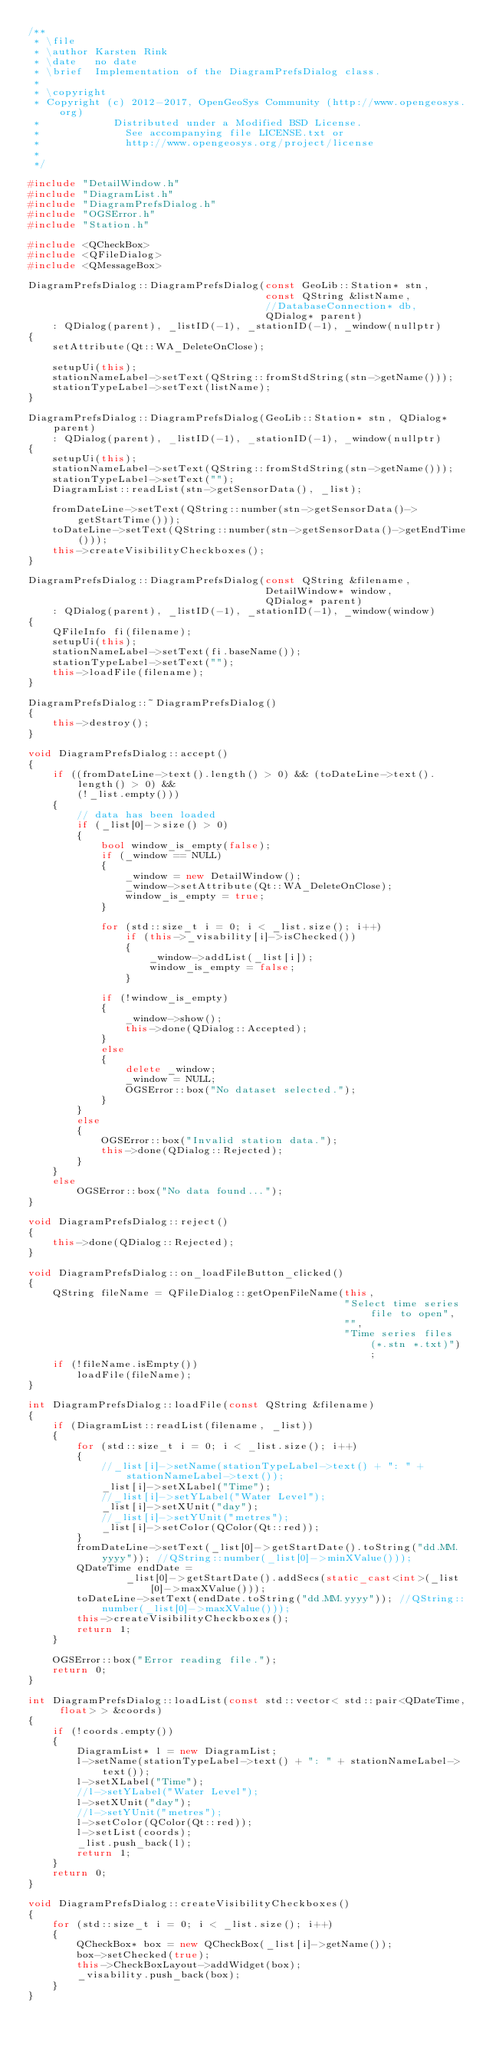Convert code to text. <code><loc_0><loc_0><loc_500><loc_500><_C++_>/**
 * \file
 * \author Karsten Rink
 * \date   no date
 * \brief  Implementation of the DiagramPrefsDialog class.
 *
 * \copyright
 * Copyright (c) 2012-2017, OpenGeoSys Community (http://www.opengeosys.org)
 *            Distributed under a Modified BSD License.
 *              See accompanying file LICENSE.txt or
 *              http://www.opengeosys.org/project/license
 *
 */

#include "DetailWindow.h"
#include "DiagramList.h"
#include "DiagramPrefsDialog.h"
#include "OGSError.h"
#include "Station.h"

#include <QCheckBox>
#include <QFileDialog>
#include <QMessageBox>

DiagramPrefsDialog::DiagramPrefsDialog(const GeoLib::Station* stn,
                                       const QString &listName,
                                       //DatabaseConnection* db,
                                       QDialog* parent)
    : QDialog(parent), _listID(-1), _stationID(-1), _window(nullptr)
{
    setAttribute(Qt::WA_DeleteOnClose);

    setupUi(this);
    stationNameLabel->setText(QString::fromStdString(stn->getName()));
    stationTypeLabel->setText(listName);
}

DiagramPrefsDialog::DiagramPrefsDialog(GeoLib::Station* stn, QDialog* parent)
    : QDialog(parent), _listID(-1), _stationID(-1), _window(nullptr)
{
    setupUi(this);
    stationNameLabel->setText(QString::fromStdString(stn->getName()));
    stationTypeLabel->setText("");
    DiagramList::readList(stn->getSensorData(), _list);

    fromDateLine->setText(QString::number(stn->getSensorData()->getStartTime()));
    toDateLine->setText(QString::number(stn->getSensorData()->getEndTime()));
    this->createVisibilityCheckboxes();
}

DiagramPrefsDialog::DiagramPrefsDialog(const QString &filename,
                                       DetailWindow* window,
                                       QDialog* parent)
    : QDialog(parent), _listID(-1), _stationID(-1), _window(window)
{
    QFileInfo fi(filename);
    setupUi(this);
    stationNameLabel->setText(fi.baseName());
    stationTypeLabel->setText("");
    this->loadFile(filename);
}

DiagramPrefsDialog::~DiagramPrefsDialog()
{
    this->destroy();
}

void DiagramPrefsDialog::accept()
{
    if ((fromDateLine->text().length() > 0) && (toDateLine->text().length() > 0) &&
        (!_list.empty()))
    {
        // data has been loaded
        if (_list[0]->size() > 0)
        {
            bool window_is_empty(false);
            if (_window == NULL)
            {
                _window = new DetailWindow();
                _window->setAttribute(Qt::WA_DeleteOnClose);
                window_is_empty = true;
            }

            for (std::size_t i = 0; i < _list.size(); i++)
                if (this->_visability[i]->isChecked())
                {
                    _window->addList(_list[i]);
                    window_is_empty = false;
                }

            if (!window_is_empty)
            {
                _window->show();
                this->done(QDialog::Accepted);
            }
            else
            {
                delete _window;
                _window = NULL;
                OGSError::box("No dataset selected.");
            }
        }
        else
        {
            OGSError::box("Invalid station data.");
            this->done(QDialog::Rejected);
        }
    }
    else
        OGSError::box("No data found...");
}

void DiagramPrefsDialog::reject()
{
    this->done(QDialog::Rejected);
}

void DiagramPrefsDialog::on_loadFileButton_clicked()
{
    QString fileName = QFileDialog::getOpenFileName(this,
                                                    "Select time series file to open",
                                                    "",
                                                    "Time series files (*.stn *.txt)");
    if (!fileName.isEmpty())
        loadFile(fileName);
}

int DiagramPrefsDialog::loadFile(const QString &filename)
{
    if (DiagramList::readList(filename, _list))
    {
        for (std::size_t i = 0; i < _list.size(); i++)
        {
            //_list[i]->setName(stationTypeLabel->text() + ": " + stationNameLabel->text());
            _list[i]->setXLabel("Time");
            //_list[i]->setYLabel("Water Level");
            _list[i]->setXUnit("day");
            //_list[i]->setYUnit("metres");
            _list[i]->setColor(QColor(Qt::red));
        }
        fromDateLine->setText(_list[0]->getStartDate().toString("dd.MM.yyyy")); //QString::number(_list[0]->minXValue()));
        QDateTime endDate =
                _list[0]->getStartDate().addSecs(static_cast<int>(_list[0]->maxXValue()));
        toDateLine->setText(endDate.toString("dd.MM.yyyy")); //QString::number(_list[0]->maxXValue()));
        this->createVisibilityCheckboxes();
        return 1;
    }

    OGSError::box("Error reading file.");
    return 0;
}

int DiagramPrefsDialog::loadList(const std::vector< std::pair<QDateTime, float> > &coords)
{
    if (!coords.empty())
    {
        DiagramList* l = new DiagramList;
        l->setName(stationTypeLabel->text() + ": " + stationNameLabel->text());
        l->setXLabel("Time");
        //l->setYLabel("Water Level");
        l->setXUnit("day");
        //l->setYUnit("metres");
        l->setColor(QColor(Qt::red));
        l->setList(coords);
        _list.push_back(l);
        return 1;
    }
    return 0;
}

void DiagramPrefsDialog::createVisibilityCheckboxes()
{
    for (std::size_t i = 0; i < _list.size(); i++)
    {
        QCheckBox* box = new QCheckBox(_list[i]->getName());
        box->setChecked(true);
        this->CheckBoxLayout->addWidget(box);
        _visability.push_back(box);
    }
}

</code> 